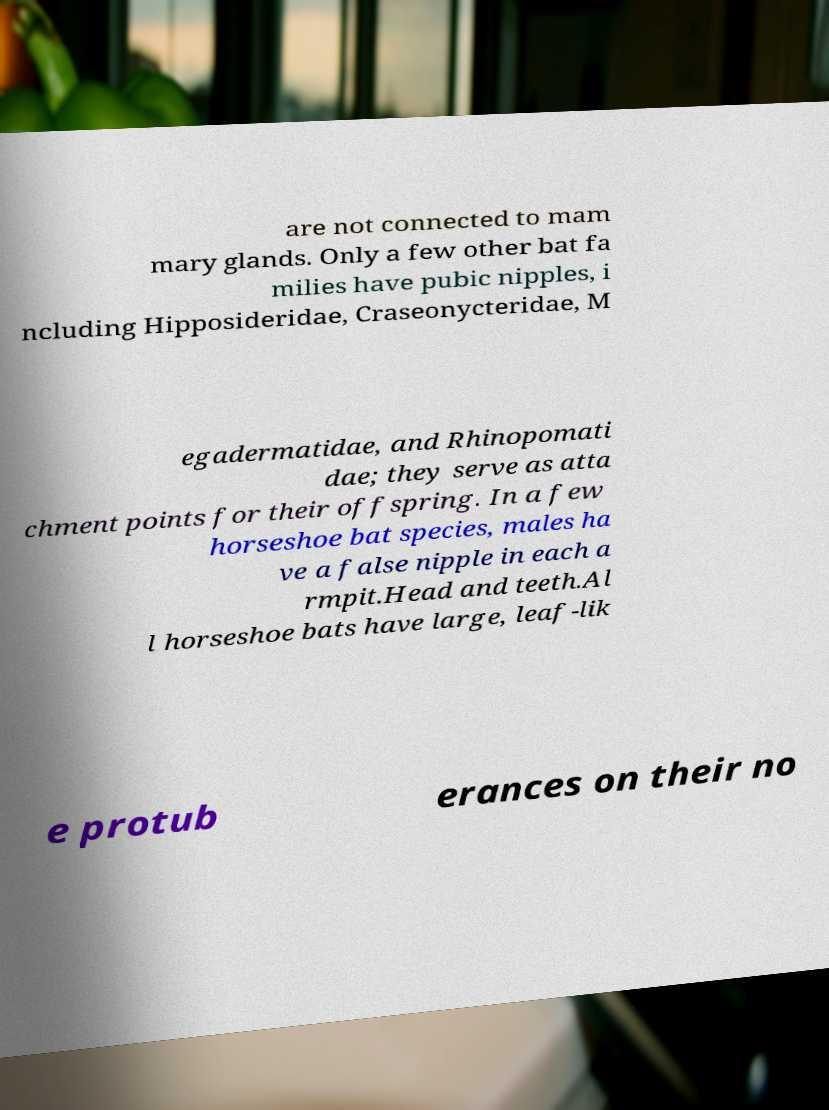Can you read and provide the text displayed in the image?This photo seems to have some interesting text. Can you extract and type it out for me? are not connected to mam mary glands. Only a few other bat fa milies have pubic nipples, i ncluding Hipposideridae, Craseonycteridae, M egadermatidae, and Rhinopomati dae; they serve as atta chment points for their offspring. In a few horseshoe bat species, males ha ve a false nipple in each a rmpit.Head and teeth.Al l horseshoe bats have large, leaf-lik e protub erances on their no 